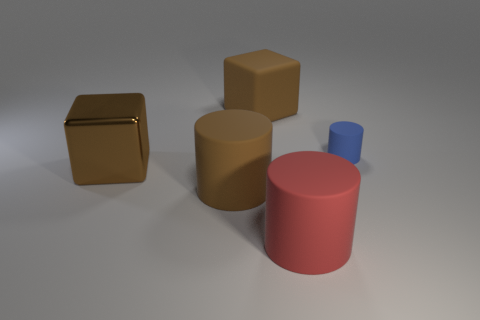Are there any other things that have the same size as the blue matte cylinder?
Give a very brief answer. No. There is a matte thing behind the small blue rubber cylinder; does it have the same shape as the metal object?
Your answer should be compact. Yes. Are there any blue cylinders?
Provide a succinct answer. Yes. Is the number of big cubes that are to the left of the brown matte block greater than the number of small red shiny objects?
Keep it short and to the point. Yes. There is a metallic cube; are there any blocks to the right of it?
Your answer should be compact. Yes. Does the blue cylinder have the same size as the red rubber cylinder?
Offer a terse response. No. What size is the rubber object that is the same shape as the big brown metal object?
Give a very brief answer. Large. The block behind the cylinder to the right of the red rubber cylinder is made of what material?
Offer a terse response. Rubber. Does the blue thing have the same shape as the big brown metal object?
Give a very brief answer. No. How many things are on the right side of the big brown matte block and behind the big metal thing?
Provide a succinct answer. 1. 